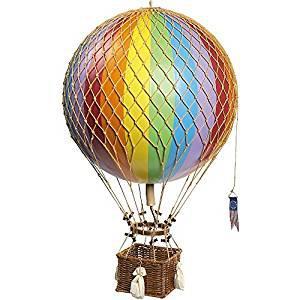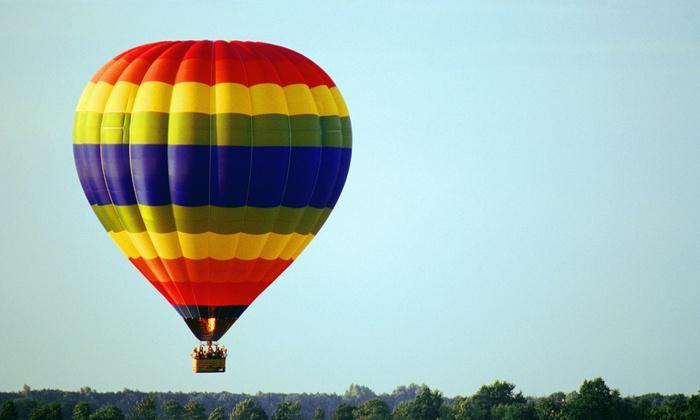The first image is the image on the left, the second image is the image on the right. Examine the images to the left and right. Is the description "There are more than 5 balloons in one of the images." accurate? Answer yes or no. No. 